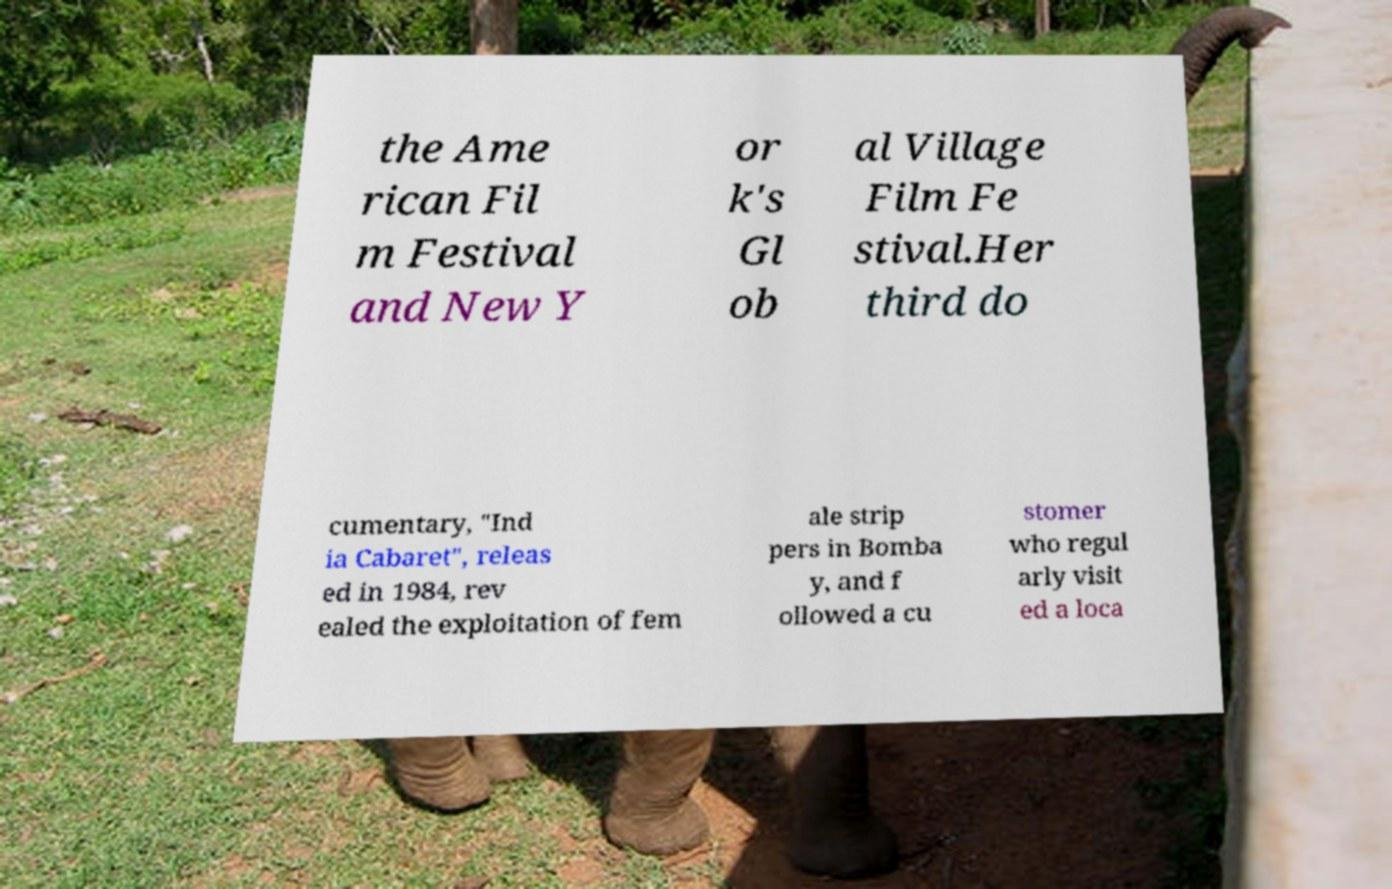For documentation purposes, I need the text within this image transcribed. Could you provide that? the Ame rican Fil m Festival and New Y or k's Gl ob al Village Film Fe stival.Her third do cumentary, "Ind ia Cabaret", releas ed in 1984, rev ealed the exploitation of fem ale strip pers in Bomba y, and f ollowed a cu stomer who regul arly visit ed a loca 